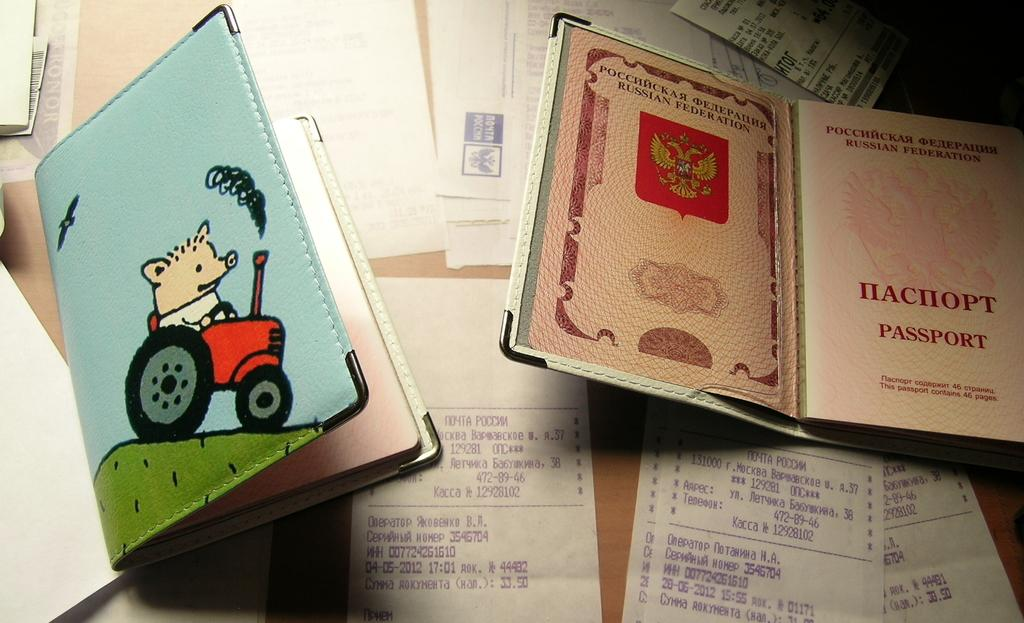<image>
Describe the image concisely. A table with lots of receipts and a notebook that says passport. 